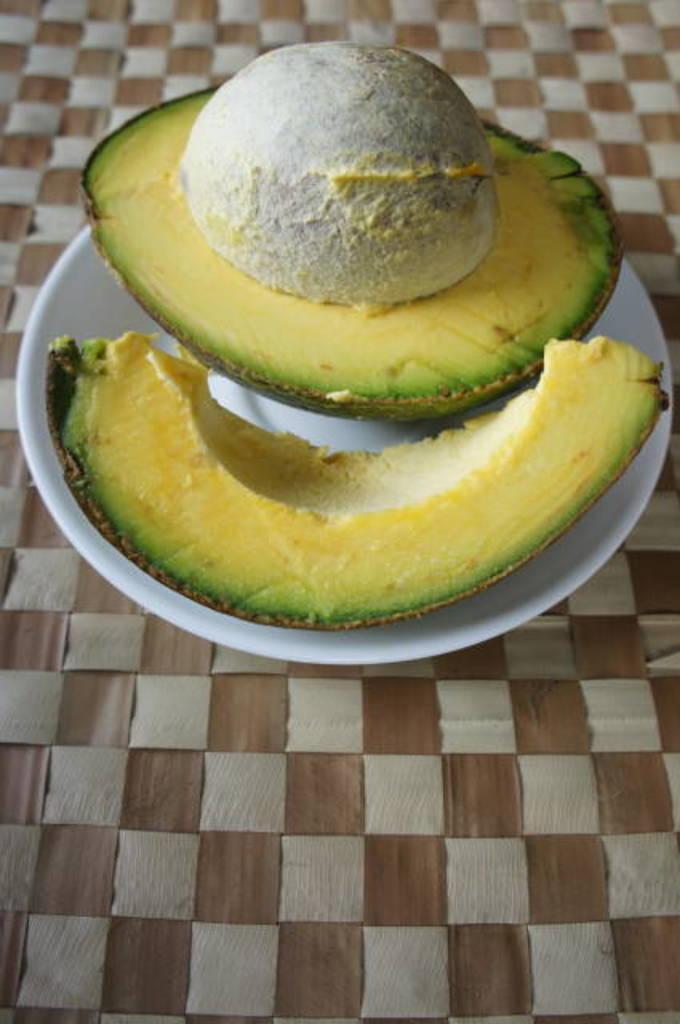How would you summarize this image in a sentence or two? This image consist of food which is on the plate, which is white in colour. 